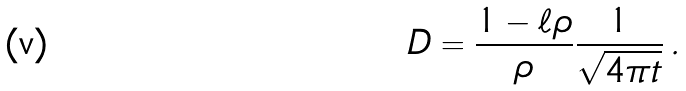<formula> <loc_0><loc_0><loc_500><loc_500>D = \frac { 1 - \ell \rho } { \rho } \frac { 1 } { \sqrt { 4 \pi t } } \, .</formula> 